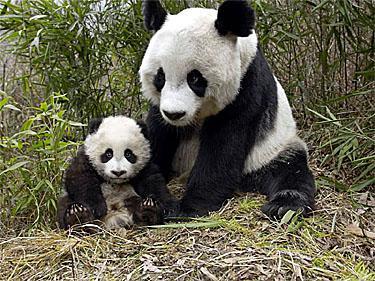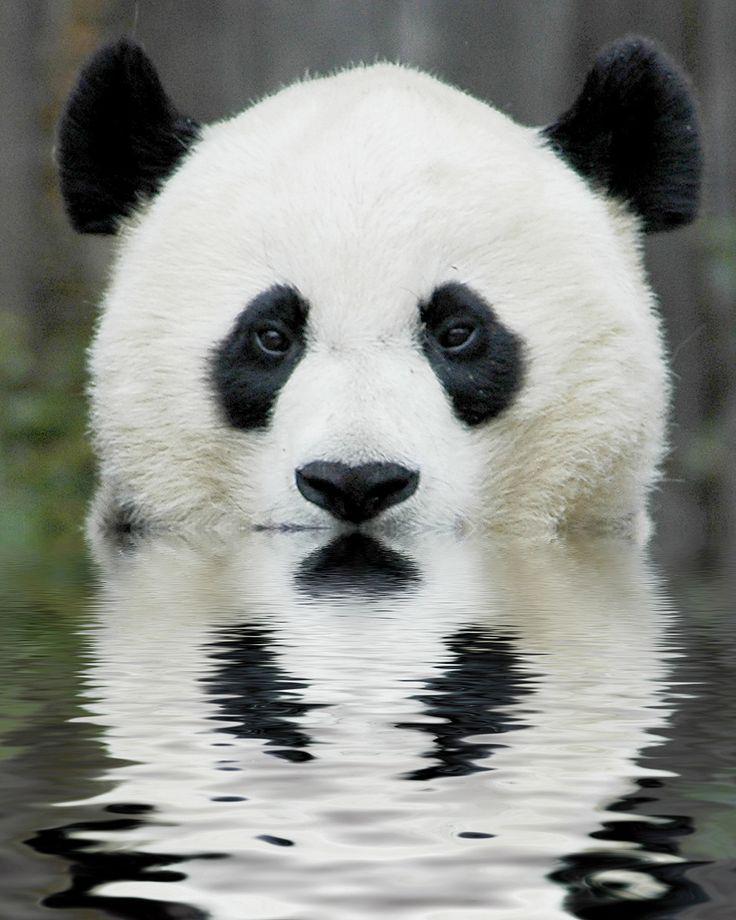The first image is the image on the left, the second image is the image on the right. Examine the images to the left and right. Is the description "the panda on the left image has its mouth open" accurate? Answer yes or no. No. 